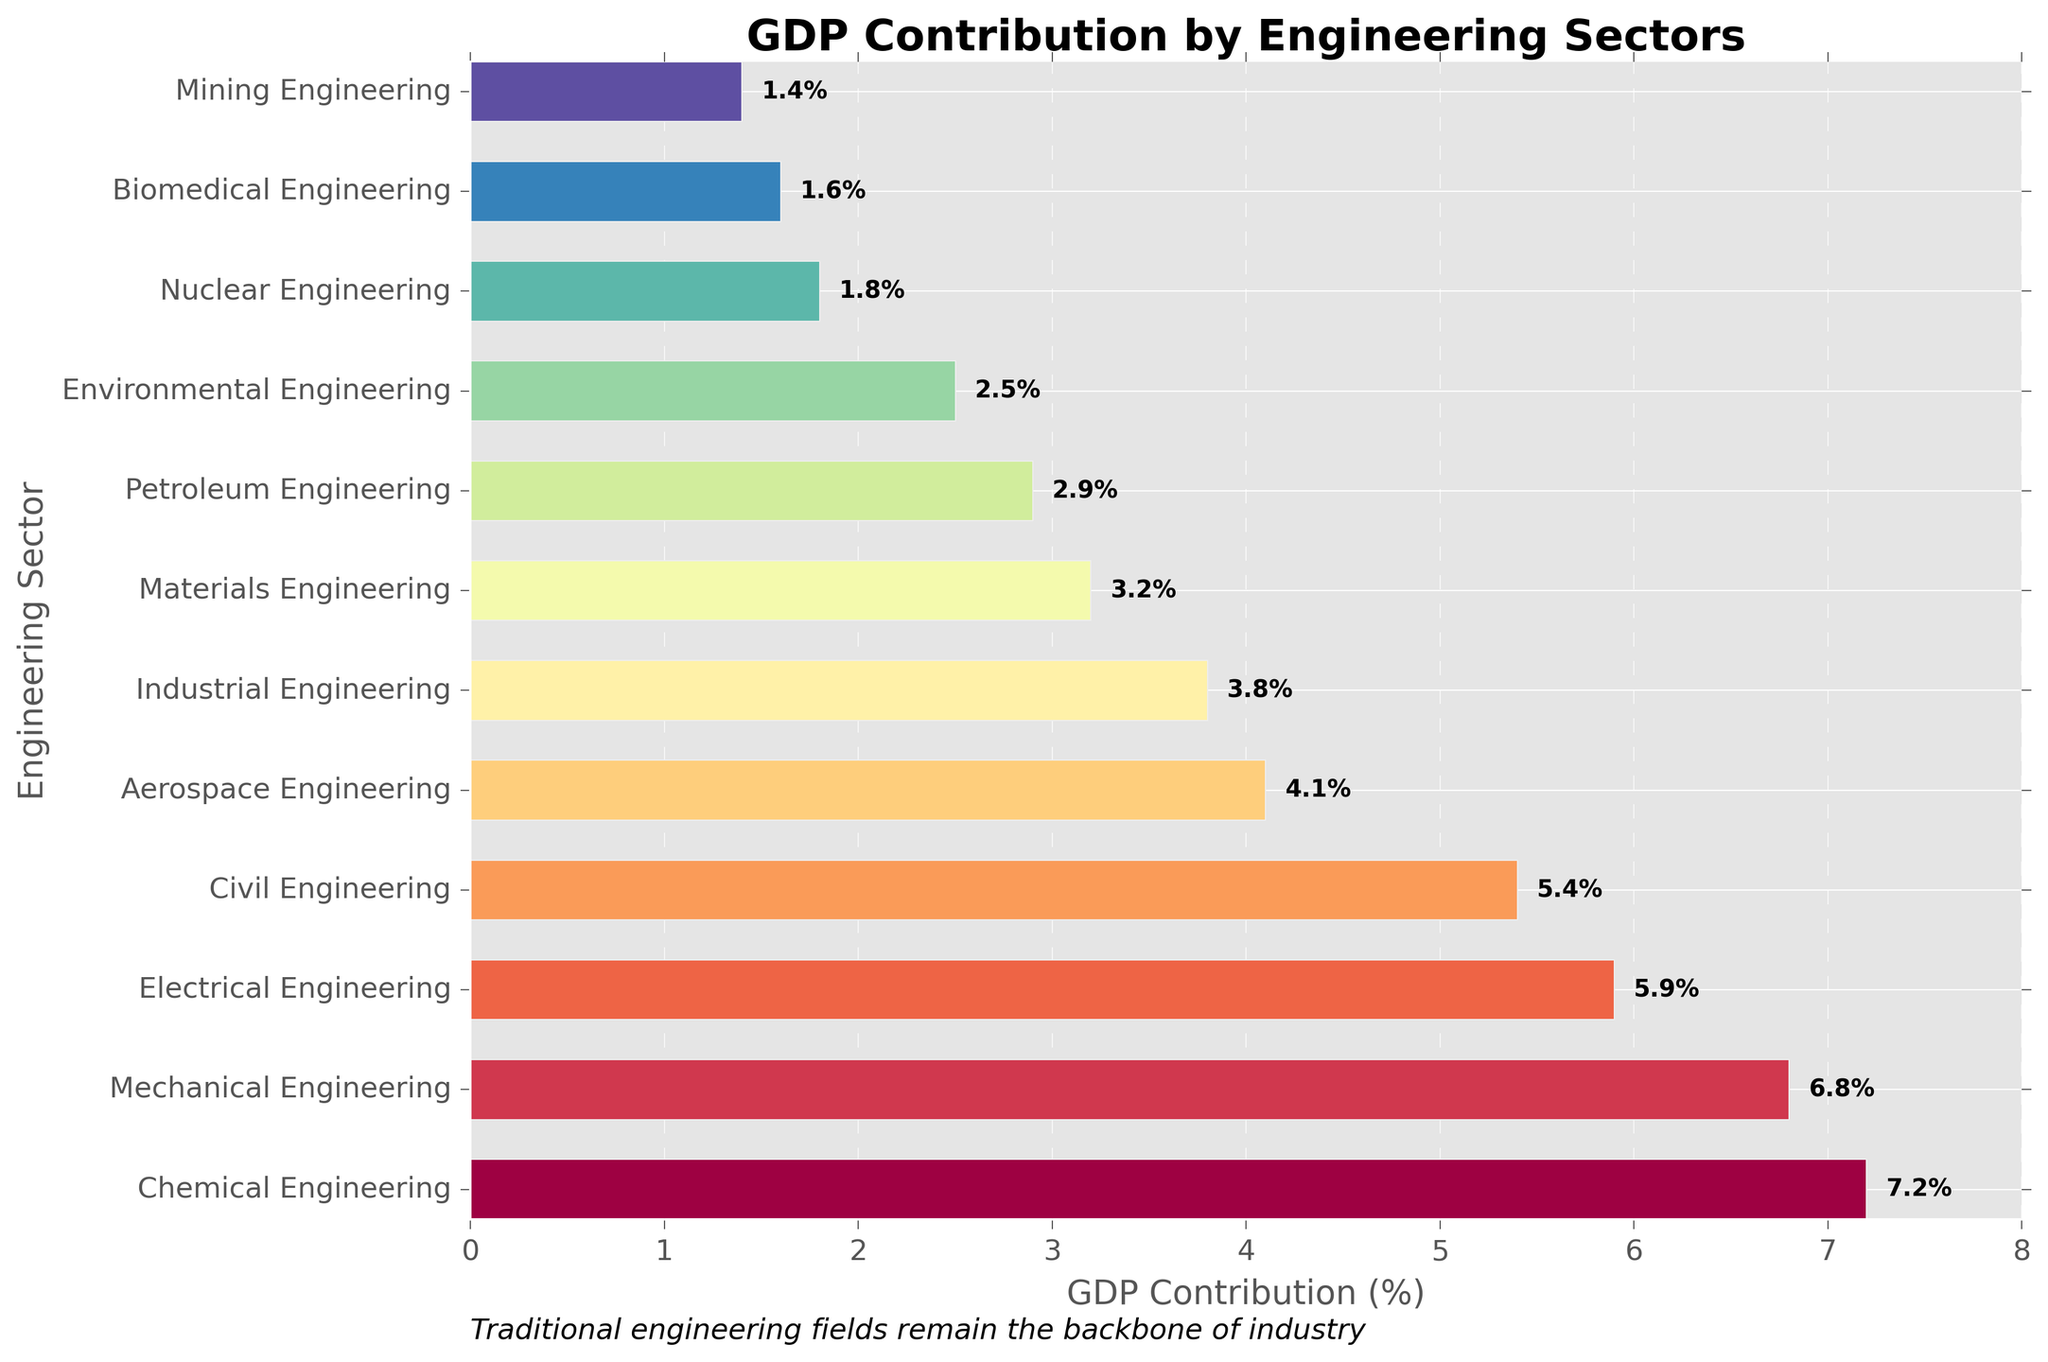what is the engineering sector contributing the most to GDP? The sector with the highest bar represents the highest GDP contribution, which is Chemical Engineering with a 7.2% contribution.
Answer: Chemical Engineering what is the total GDP contribution of Chemical, Mechanical, and Electrical Engineering combined? Add the contributions of Chemical Engineering (7.2%), Mechanical Engineering (6.8%), and Electrical Engineering (5.9%) respectively. 7.2 + 6.8 + 5.9 = 19.9
Answer: 19.9% what is the difference in GDP contribution between Industrial and Civil Engineering? Subtract the GDP contribution of Civil Engineering (5.4%) from Industrial Engineering (3.8%). 5.4 - 3.8 = 1.6
Answer: 1.6% Which engineering sector has nearly half the GDP contribution of Mechanical Engineering? Mechanical Engineering contributes 6.8%, and half of 6.8 is 3.4. The closest sector to 3.4% is Materials Engineering, which contributes 3.2%.
Answer: Materials Engineering Which sector contributes less to GDP than Environmental Engineering but more than Mining Engineering? Environmental Engineering contributes 2.5%, and Mining Engineering contributes 1.4%. Between these two values are Petroleum Engineering (2.9%) and Nuclear Engineering (1.8%). The only sector between these contributions is Nuclear Engineering.
Answer: Nuclear Engineering What is the average GDP contribution of all engineering sectors listed? Sum the contributions of all sectors and then divide by the number of sectors: (7.2 + 6.8 + 5.9 + 5.4 + 4.1 + 3.8 + 3.2 + 2.9 + 2.5 + 1.8 + 1.6 + 1.4) / 12 = 45.6 / 12 = 3.8
Answer: 3.8% Which two engineering sectors have the closest GDP contribution values? Compare contributions and find the smallest difference: Civil Engineering (5.4%) and Electrical Engineering (5.9%) have a difference of 0.5.
Answer: Civil Engineering and Electrical Engineering Is the GDP contribution from Biomedical Engineering greater than the GDP contribution from Mining Engineering? Compare the two values: Biomedical Engineering (1.6%) is greater than Mining Engineering (1.4%).
Answer: Yes How much more does Chemical Engineering contribute to GDP than Aerospace Engineering? Subtract the GDP contribution of Aerospace Engineering (4.1%) from Chemical Engineering (7.2%). 7.2 - 4.1 = 3.1
Answer: 3.1% Is there a visible engineering sector that contributes less than 2% to GDP? Check the bars and their labels for sectors with contributions less than 2%. Both Nuclear Engineering (1.8%) and Biomedical Engineering (1.6%), as well as Mining Engineering (1.4%) fall into this category.
Answer: Yes 